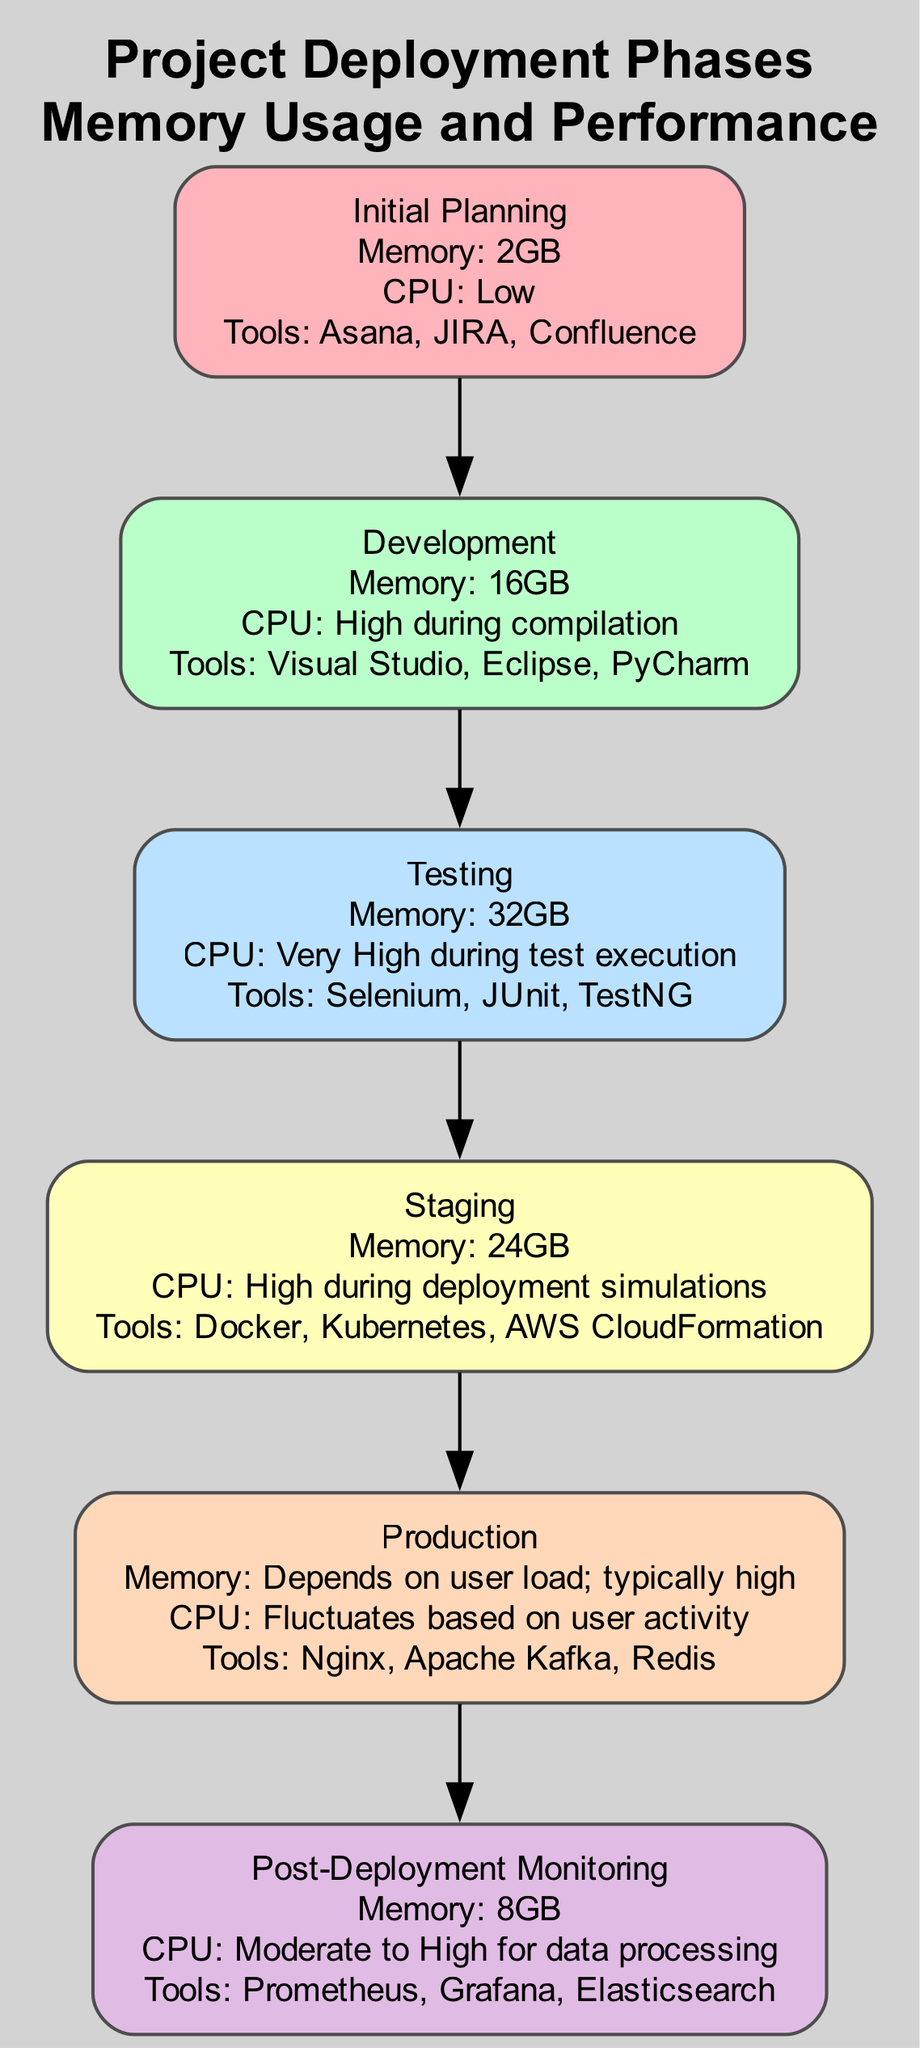What is the peak memory usage during the Testing phase? The Testing phase has a specified peak memory usage of 32GB mentioned in the diagram.
Answer: 32GB Which tools are used during the Development phase? The Development phase lists the tools: Visual Studio, Eclipse, and PyCharm. This information can be found in the corresponding node for the Development phase.
Answer: Visual Studio, Eclipse, PyCharm What is the relationship between the Initial Planning and Development phases? The diagram shows a directional edge from Initial Planning to Development, indicating that the Development phase follows the Initial Planning phase in the deployment process.
Answer: Development follows Initial Planning What is the total number of phases depicted in the diagram? By counting the nodes in the diagram, there are six distinct phases, which can be observed visually as the boxes representing each phase.
Answer: 6 During which phase is memory usage lowest according to the diagram? The Initial Planning phase is indicated to have minimal memory usage, specifically listed as 2GB, making it the phase with the lowest memory usage.
Answer: Initial Planning How does CPU usage in the Staging phase compare to that in the Development phase? The Staging phase has high CPU usage during deployment simulations, while the Development phase experiences high CPU usage during compilation. Both are high, but the context differs (compilation vs. deployment).
Answer: Both are high Which phase experiences the highest overall memory usage? The Testing phase has the highest peak memory usage at 32GB, noted in the phase’s memory usage patterns.
Answer: Testing What is the primary function of the tools used in the Post-Deployment Monitoring phase? The tools in the Post-Deployment Monitoring phase (Prometheus, Grafana, Elasticsearch) are focused on monitoring tools and data analytics, as specified in the diagram.
Answer: Monitoring and data analytics What is the level of disk I/O metrics during the Production phase? The Production phase has consistent disk I/O metrics, with peaks during heavy load, indicating varying operations based on user load and activities.
Answer: Consistent with peaks during heavy load 